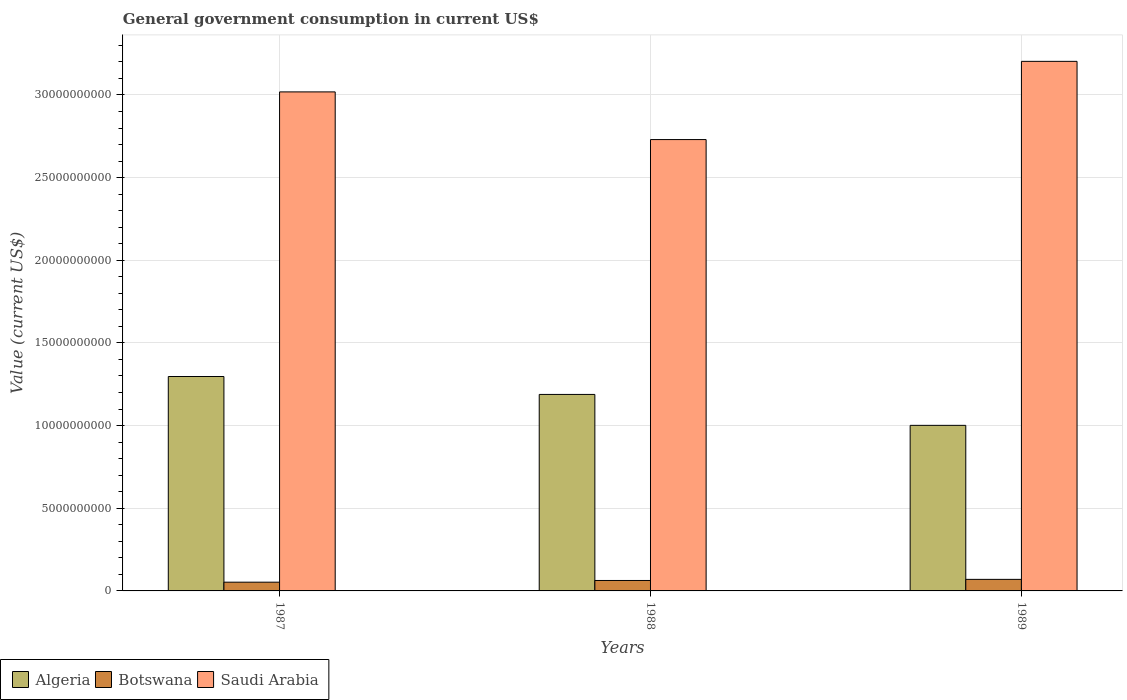How many different coloured bars are there?
Your answer should be compact. 3. How many groups of bars are there?
Keep it short and to the point. 3. Are the number of bars per tick equal to the number of legend labels?
Your response must be concise. Yes. Are the number of bars on each tick of the X-axis equal?
Offer a terse response. Yes. How many bars are there on the 3rd tick from the left?
Give a very brief answer. 3. How many bars are there on the 1st tick from the right?
Keep it short and to the point. 3. What is the label of the 3rd group of bars from the left?
Provide a succinct answer. 1989. In how many cases, is the number of bars for a given year not equal to the number of legend labels?
Give a very brief answer. 0. What is the government conusmption in Algeria in 1987?
Provide a succinct answer. 1.30e+1. Across all years, what is the maximum government conusmption in Botswana?
Provide a short and direct response. 6.99e+08. Across all years, what is the minimum government conusmption in Algeria?
Offer a very short reply. 1.00e+1. In which year was the government conusmption in Algeria maximum?
Keep it short and to the point. 1987. What is the total government conusmption in Saudi Arabia in the graph?
Keep it short and to the point. 8.95e+1. What is the difference between the government conusmption in Botswana in 1987 and that in 1988?
Provide a succinct answer. -1.03e+08. What is the difference between the government conusmption in Algeria in 1987 and the government conusmption in Saudi Arabia in 1989?
Ensure brevity in your answer.  -1.91e+1. What is the average government conusmption in Botswana per year?
Provide a short and direct response. 6.20e+08. In the year 1988, what is the difference between the government conusmption in Algeria and government conusmption in Botswana?
Your response must be concise. 1.13e+1. In how many years, is the government conusmption in Botswana greater than 14000000000 US$?
Your answer should be compact. 0. What is the ratio of the government conusmption in Botswana in 1988 to that in 1989?
Your answer should be compact. 0.9. Is the government conusmption in Saudi Arabia in 1987 less than that in 1988?
Offer a terse response. No. What is the difference between the highest and the second highest government conusmption in Saudi Arabia?
Offer a very short reply. 1.85e+09. What is the difference between the highest and the lowest government conusmption in Algeria?
Ensure brevity in your answer.  2.95e+09. In how many years, is the government conusmption in Botswana greater than the average government conusmption in Botswana taken over all years?
Provide a succinct answer. 2. What does the 1st bar from the left in 1988 represents?
Keep it short and to the point. Algeria. What does the 3rd bar from the right in 1989 represents?
Your answer should be very brief. Algeria. How many bars are there?
Keep it short and to the point. 9. Are all the bars in the graph horizontal?
Your response must be concise. No. How many years are there in the graph?
Offer a very short reply. 3. What is the difference between two consecutive major ticks on the Y-axis?
Keep it short and to the point. 5.00e+09. Are the values on the major ticks of Y-axis written in scientific E-notation?
Provide a short and direct response. No. Does the graph contain any zero values?
Ensure brevity in your answer.  No. Where does the legend appear in the graph?
Ensure brevity in your answer.  Bottom left. How are the legend labels stacked?
Offer a terse response. Horizontal. What is the title of the graph?
Make the answer very short. General government consumption in current US$. What is the label or title of the Y-axis?
Provide a short and direct response. Value (current US$). What is the Value (current US$) in Algeria in 1987?
Offer a terse response. 1.30e+1. What is the Value (current US$) in Botswana in 1987?
Your answer should be compact. 5.29e+08. What is the Value (current US$) of Saudi Arabia in 1987?
Ensure brevity in your answer.  3.02e+1. What is the Value (current US$) of Algeria in 1988?
Keep it short and to the point. 1.19e+1. What is the Value (current US$) in Botswana in 1988?
Give a very brief answer. 6.32e+08. What is the Value (current US$) of Saudi Arabia in 1988?
Offer a terse response. 2.73e+1. What is the Value (current US$) in Algeria in 1989?
Your answer should be very brief. 1.00e+1. What is the Value (current US$) of Botswana in 1989?
Provide a succinct answer. 6.99e+08. What is the Value (current US$) in Saudi Arabia in 1989?
Ensure brevity in your answer.  3.20e+1. Across all years, what is the maximum Value (current US$) of Algeria?
Offer a terse response. 1.30e+1. Across all years, what is the maximum Value (current US$) in Botswana?
Provide a short and direct response. 6.99e+08. Across all years, what is the maximum Value (current US$) of Saudi Arabia?
Your response must be concise. 3.20e+1. Across all years, what is the minimum Value (current US$) of Algeria?
Ensure brevity in your answer.  1.00e+1. Across all years, what is the minimum Value (current US$) in Botswana?
Make the answer very short. 5.29e+08. Across all years, what is the minimum Value (current US$) in Saudi Arabia?
Offer a very short reply. 2.73e+1. What is the total Value (current US$) of Algeria in the graph?
Give a very brief answer. 3.49e+1. What is the total Value (current US$) in Botswana in the graph?
Your answer should be compact. 1.86e+09. What is the total Value (current US$) in Saudi Arabia in the graph?
Your answer should be compact. 8.95e+1. What is the difference between the Value (current US$) of Algeria in 1987 and that in 1988?
Offer a terse response. 1.08e+09. What is the difference between the Value (current US$) in Botswana in 1987 and that in 1988?
Your response must be concise. -1.03e+08. What is the difference between the Value (current US$) in Saudi Arabia in 1987 and that in 1988?
Your response must be concise. 2.88e+09. What is the difference between the Value (current US$) in Algeria in 1987 and that in 1989?
Your response must be concise. 2.95e+09. What is the difference between the Value (current US$) of Botswana in 1987 and that in 1989?
Your answer should be compact. -1.70e+08. What is the difference between the Value (current US$) of Saudi Arabia in 1987 and that in 1989?
Make the answer very short. -1.85e+09. What is the difference between the Value (current US$) of Algeria in 1988 and that in 1989?
Your answer should be compact. 1.87e+09. What is the difference between the Value (current US$) in Botswana in 1988 and that in 1989?
Keep it short and to the point. -6.72e+07. What is the difference between the Value (current US$) in Saudi Arabia in 1988 and that in 1989?
Make the answer very short. -4.73e+09. What is the difference between the Value (current US$) in Algeria in 1987 and the Value (current US$) in Botswana in 1988?
Give a very brief answer. 1.23e+1. What is the difference between the Value (current US$) in Algeria in 1987 and the Value (current US$) in Saudi Arabia in 1988?
Give a very brief answer. -1.43e+1. What is the difference between the Value (current US$) of Botswana in 1987 and the Value (current US$) of Saudi Arabia in 1988?
Your response must be concise. -2.68e+1. What is the difference between the Value (current US$) in Algeria in 1987 and the Value (current US$) in Botswana in 1989?
Keep it short and to the point. 1.23e+1. What is the difference between the Value (current US$) of Algeria in 1987 and the Value (current US$) of Saudi Arabia in 1989?
Provide a succinct answer. -1.91e+1. What is the difference between the Value (current US$) in Botswana in 1987 and the Value (current US$) in Saudi Arabia in 1989?
Ensure brevity in your answer.  -3.15e+1. What is the difference between the Value (current US$) of Algeria in 1988 and the Value (current US$) of Botswana in 1989?
Make the answer very short. 1.12e+1. What is the difference between the Value (current US$) of Algeria in 1988 and the Value (current US$) of Saudi Arabia in 1989?
Offer a very short reply. -2.01e+1. What is the difference between the Value (current US$) of Botswana in 1988 and the Value (current US$) of Saudi Arabia in 1989?
Your response must be concise. -3.14e+1. What is the average Value (current US$) of Algeria per year?
Provide a short and direct response. 1.16e+1. What is the average Value (current US$) in Botswana per year?
Give a very brief answer. 6.20e+08. What is the average Value (current US$) in Saudi Arabia per year?
Offer a very short reply. 2.98e+1. In the year 1987, what is the difference between the Value (current US$) in Algeria and Value (current US$) in Botswana?
Offer a very short reply. 1.24e+1. In the year 1987, what is the difference between the Value (current US$) in Algeria and Value (current US$) in Saudi Arabia?
Provide a short and direct response. -1.72e+1. In the year 1987, what is the difference between the Value (current US$) of Botswana and Value (current US$) of Saudi Arabia?
Ensure brevity in your answer.  -2.97e+1. In the year 1988, what is the difference between the Value (current US$) of Algeria and Value (current US$) of Botswana?
Your answer should be very brief. 1.13e+1. In the year 1988, what is the difference between the Value (current US$) of Algeria and Value (current US$) of Saudi Arabia?
Provide a succinct answer. -1.54e+1. In the year 1988, what is the difference between the Value (current US$) of Botswana and Value (current US$) of Saudi Arabia?
Your answer should be very brief. -2.67e+1. In the year 1989, what is the difference between the Value (current US$) of Algeria and Value (current US$) of Botswana?
Provide a short and direct response. 9.32e+09. In the year 1989, what is the difference between the Value (current US$) in Algeria and Value (current US$) in Saudi Arabia?
Make the answer very short. -2.20e+1. In the year 1989, what is the difference between the Value (current US$) in Botswana and Value (current US$) in Saudi Arabia?
Provide a succinct answer. -3.13e+1. What is the ratio of the Value (current US$) of Algeria in 1987 to that in 1988?
Offer a terse response. 1.09. What is the ratio of the Value (current US$) of Botswana in 1987 to that in 1988?
Your answer should be compact. 0.84. What is the ratio of the Value (current US$) in Saudi Arabia in 1987 to that in 1988?
Offer a terse response. 1.11. What is the ratio of the Value (current US$) of Algeria in 1987 to that in 1989?
Offer a very short reply. 1.29. What is the ratio of the Value (current US$) in Botswana in 1987 to that in 1989?
Give a very brief answer. 0.76. What is the ratio of the Value (current US$) of Saudi Arabia in 1987 to that in 1989?
Offer a very short reply. 0.94. What is the ratio of the Value (current US$) in Algeria in 1988 to that in 1989?
Provide a succinct answer. 1.19. What is the ratio of the Value (current US$) in Botswana in 1988 to that in 1989?
Keep it short and to the point. 0.9. What is the ratio of the Value (current US$) of Saudi Arabia in 1988 to that in 1989?
Your response must be concise. 0.85. What is the difference between the highest and the second highest Value (current US$) in Algeria?
Give a very brief answer. 1.08e+09. What is the difference between the highest and the second highest Value (current US$) in Botswana?
Your answer should be compact. 6.72e+07. What is the difference between the highest and the second highest Value (current US$) in Saudi Arabia?
Offer a terse response. 1.85e+09. What is the difference between the highest and the lowest Value (current US$) in Algeria?
Provide a short and direct response. 2.95e+09. What is the difference between the highest and the lowest Value (current US$) in Botswana?
Your response must be concise. 1.70e+08. What is the difference between the highest and the lowest Value (current US$) of Saudi Arabia?
Provide a short and direct response. 4.73e+09. 